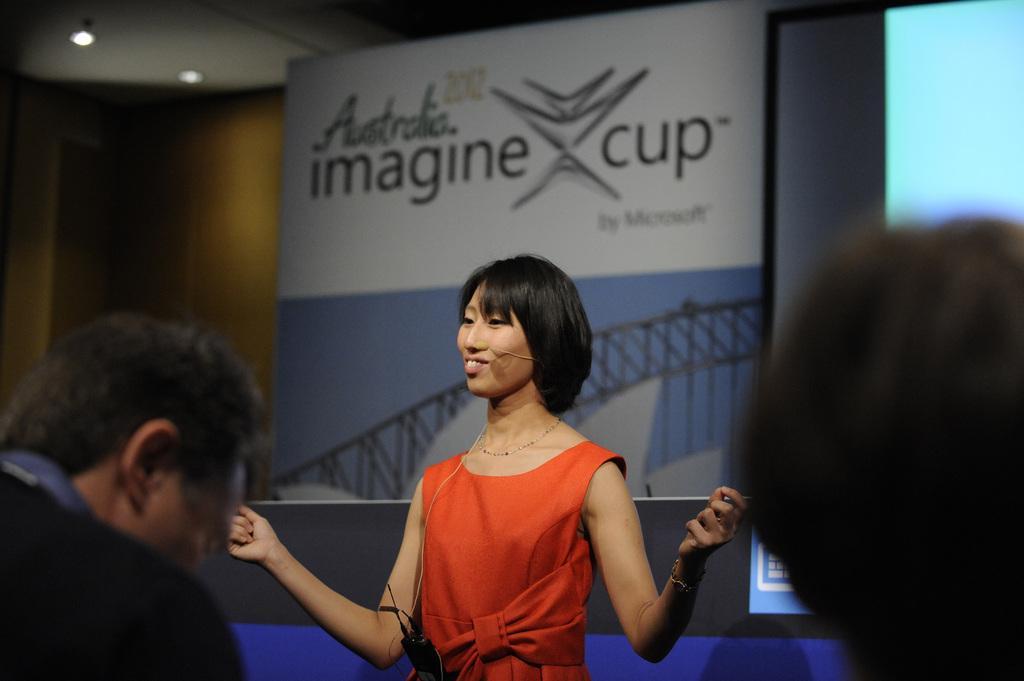Can you describe this image briefly? In this image I see a woman over here who is wearing orange color dress and I see the black color thing over here and I see that she is smiling and I see 2 persons over here. In the background I see the board on which there is something written and I see the screen over here and I see the lights over here. 